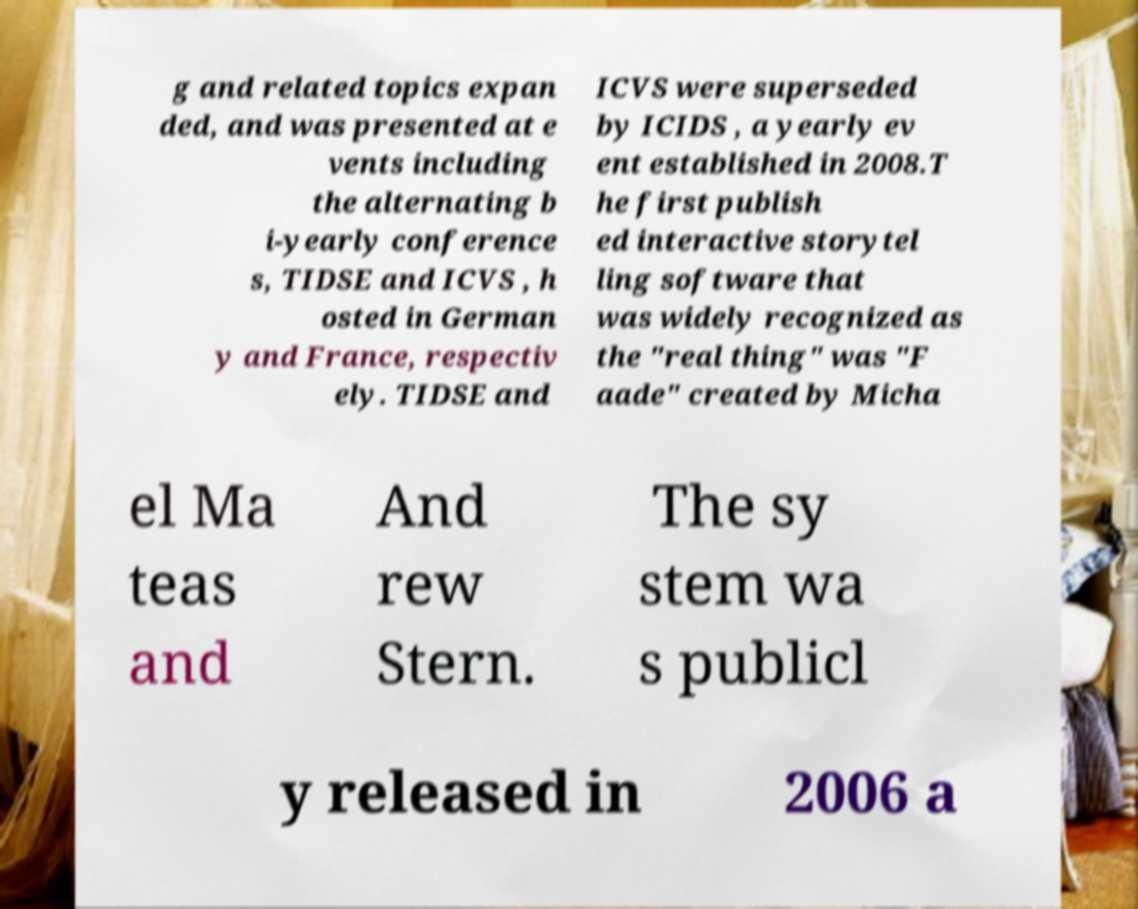There's text embedded in this image that I need extracted. Can you transcribe it verbatim? g and related topics expan ded, and was presented at e vents including the alternating b i-yearly conference s, TIDSE and ICVS , h osted in German y and France, respectiv ely. TIDSE and ICVS were superseded by ICIDS , a yearly ev ent established in 2008.T he first publish ed interactive storytel ling software that was widely recognized as the "real thing" was "F aade" created by Micha el Ma teas and And rew Stern. The sy stem wa s publicl y released in 2006 a 